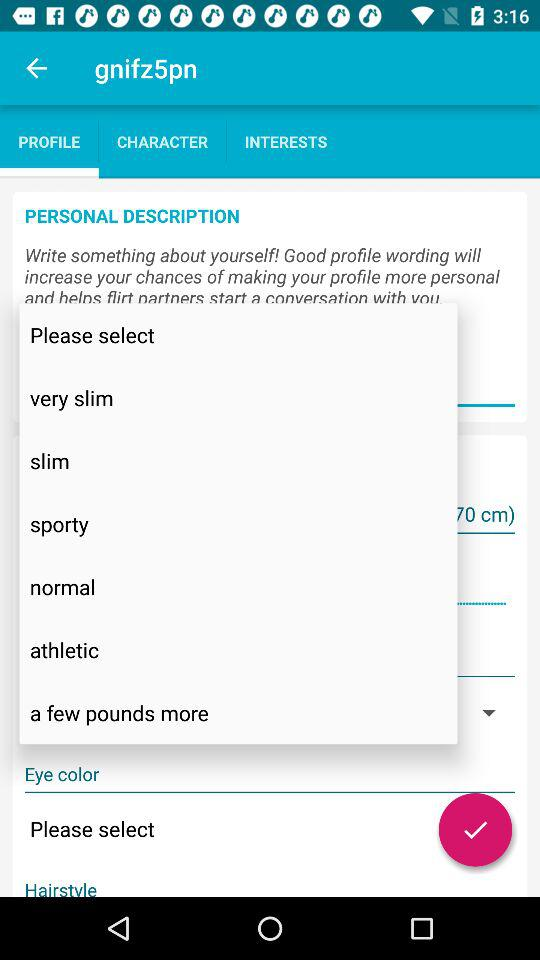Which tab is selected? The selected tab is "PROFILE". 